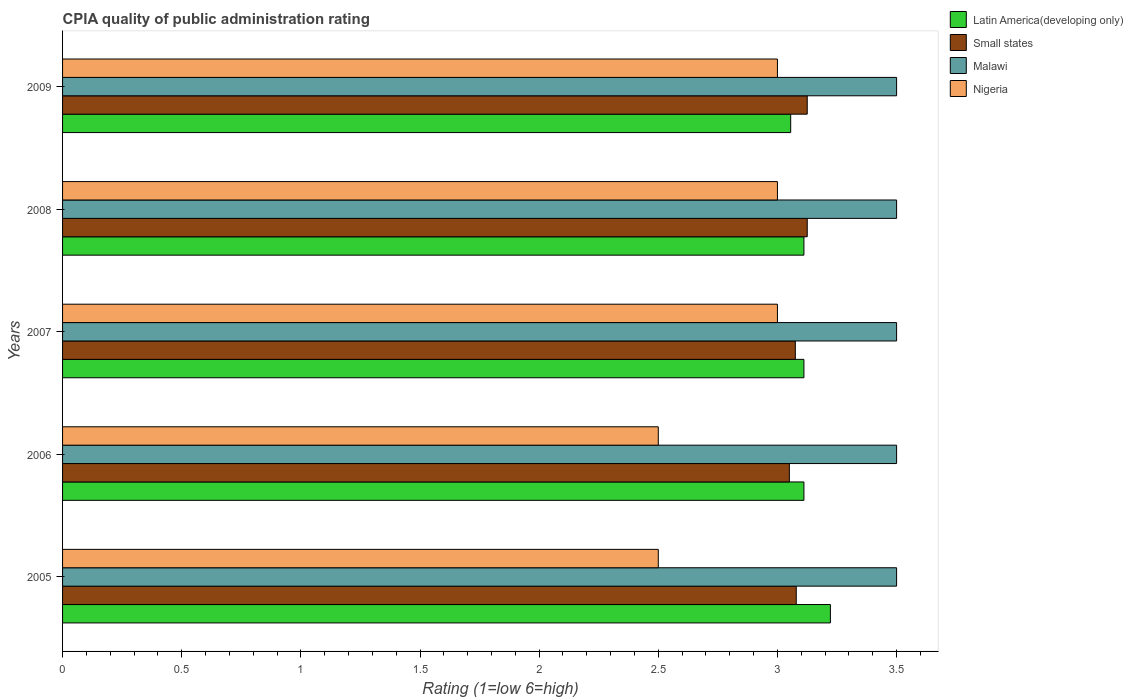How many groups of bars are there?
Keep it short and to the point. 5. Are the number of bars on each tick of the Y-axis equal?
Provide a succinct answer. Yes. What is the label of the 4th group of bars from the top?
Give a very brief answer. 2006. What is the CPIA rating in Small states in 2007?
Make the answer very short. 3.08. Across all years, what is the maximum CPIA rating in Small states?
Your answer should be compact. 3.12. Across all years, what is the minimum CPIA rating in Small states?
Your response must be concise. 3.05. In which year was the CPIA rating in Malawi maximum?
Your response must be concise. 2005. In which year was the CPIA rating in Malawi minimum?
Provide a short and direct response. 2005. What is the total CPIA rating in Nigeria in the graph?
Ensure brevity in your answer.  14. What is the difference between the CPIA rating in Latin America(developing only) in 2009 and the CPIA rating in Small states in 2007?
Keep it short and to the point. -0.02. In the year 2006, what is the difference between the CPIA rating in Malawi and CPIA rating in Latin America(developing only)?
Provide a short and direct response. 0.39. Is the difference between the CPIA rating in Malawi in 2006 and 2008 greater than the difference between the CPIA rating in Latin America(developing only) in 2006 and 2008?
Your answer should be compact. No. What is the difference between the highest and the second highest CPIA rating in Small states?
Keep it short and to the point. 0. What is the difference between the highest and the lowest CPIA rating in Latin America(developing only)?
Your answer should be compact. 0.17. What does the 3rd bar from the top in 2006 represents?
Ensure brevity in your answer.  Small states. What does the 2nd bar from the bottom in 2006 represents?
Your answer should be compact. Small states. Is it the case that in every year, the sum of the CPIA rating in Nigeria and CPIA rating in Small states is greater than the CPIA rating in Latin America(developing only)?
Keep it short and to the point. Yes. Are all the bars in the graph horizontal?
Your answer should be very brief. Yes. Does the graph contain any zero values?
Offer a terse response. No. What is the title of the graph?
Keep it short and to the point. CPIA quality of public administration rating. What is the label or title of the X-axis?
Ensure brevity in your answer.  Rating (1=low 6=high). What is the label or title of the Y-axis?
Your answer should be compact. Years. What is the Rating (1=low 6=high) in Latin America(developing only) in 2005?
Provide a succinct answer. 3.22. What is the Rating (1=low 6=high) in Small states in 2005?
Offer a terse response. 3.08. What is the Rating (1=low 6=high) of Nigeria in 2005?
Your answer should be very brief. 2.5. What is the Rating (1=low 6=high) in Latin America(developing only) in 2006?
Provide a succinct answer. 3.11. What is the Rating (1=low 6=high) of Small states in 2006?
Make the answer very short. 3.05. What is the Rating (1=low 6=high) in Nigeria in 2006?
Offer a terse response. 2.5. What is the Rating (1=low 6=high) of Latin America(developing only) in 2007?
Offer a very short reply. 3.11. What is the Rating (1=low 6=high) in Small states in 2007?
Keep it short and to the point. 3.08. What is the Rating (1=low 6=high) of Malawi in 2007?
Give a very brief answer. 3.5. What is the Rating (1=low 6=high) of Nigeria in 2007?
Give a very brief answer. 3. What is the Rating (1=low 6=high) of Latin America(developing only) in 2008?
Offer a very short reply. 3.11. What is the Rating (1=low 6=high) in Small states in 2008?
Offer a terse response. 3.12. What is the Rating (1=low 6=high) in Nigeria in 2008?
Your response must be concise. 3. What is the Rating (1=low 6=high) of Latin America(developing only) in 2009?
Give a very brief answer. 3.06. What is the Rating (1=low 6=high) in Small states in 2009?
Offer a terse response. 3.12. What is the Rating (1=low 6=high) of Malawi in 2009?
Make the answer very short. 3.5. Across all years, what is the maximum Rating (1=low 6=high) in Latin America(developing only)?
Your answer should be very brief. 3.22. Across all years, what is the maximum Rating (1=low 6=high) in Small states?
Your response must be concise. 3.12. Across all years, what is the maximum Rating (1=low 6=high) in Malawi?
Ensure brevity in your answer.  3.5. Across all years, what is the minimum Rating (1=low 6=high) of Latin America(developing only)?
Your answer should be very brief. 3.06. Across all years, what is the minimum Rating (1=low 6=high) in Small states?
Make the answer very short. 3.05. Across all years, what is the minimum Rating (1=low 6=high) in Malawi?
Offer a terse response. 3.5. What is the total Rating (1=low 6=high) in Latin America(developing only) in the graph?
Offer a very short reply. 15.61. What is the total Rating (1=low 6=high) in Small states in the graph?
Make the answer very short. 15.45. What is the total Rating (1=low 6=high) in Malawi in the graph?
Offer a very short reply. 17.5. What is the difference between the Rating (1=low 6=high) in Latin America(developing only) in 2005 and that in 2006?
Your answer should be very brief. 0.11. What is the difference between the Rating (1=low 6=high) in Small states in 2005 and that in 2006?
Give a very brief answer. 0.03. What is the difference between the Rating (1=low 6=high) of Malawi in 2005 and that in 2006?
Offer a very short reply. 0. What is the difference between the Rating (1=low 6=high) in Small states in 2005 and that in 2007?
Make the answer very short. 0. What is the difference between the Rating (1=low 6=high) in Nigeria in 2005 and that in 2007?
Make the answer very short. -0.5. What is the difference between the Rating (1=low 6=high) in Latin America(developing only) in 2005 and that in 2008?
Make the answer very short. 0.11. What is the difference between the Rating (1=low 6=high) of Small states in 2005 and that in 2008?
Provide a succinct answer. -0.05. What is the difference between the Rating (1=low 6=high) of Nigeria in 2005 and that in 2008?
Offer a very short reply. -0.5. What is the difference between the Rating (1=low 6=high) of Small states in 2005 and that in 2009?
Your response must be concise. -0.05. What is the difference between the Rating (1=low 6=high) in Small states in 2006 and that in 2007?
Provide a short and direct response. -0.03. What is the difference between the Rating (1=low 6=high) of Malawi in 2006 and that in 2007?
Keep it short and to the point. 0. What is the difference between the Rating (1=low 6=high) of Small states in 2006 and that in 2008?
Give a very brief answer. -0.07. What is the difference between the Rating (1=low 6=high) of Nigeria in 2006 and that in 2008?
Ensure brevity in your answer.  -0.5. What is the difference between the Rating (1=low 6=high) in Latin America(developing only) in 2006 and that in 2009?
Keep it short and to the point. 0.06. What is the difference between the Rating (1=low 6=high) of Small states in 2006 and that in 2009?
Ensure brevity in your answer.  -0.07. What is the difference between the Rating (1=low 6=high) of Malawi in 2006 and that in 2009?
Offer a very short reply. 0. What is the difference between the Rating (1=low 6=high) of Nigeria in 2006 and that in 2009?
Provide a short and direct response. -0.5. What is the difference between the Rating (1=low 6=high) of Small states in 2007 and that in 2008?
Your answer should be very brief. -0.05. What is the difference between the Rating (1=low 6=high) of Malawi in 2007 and that in 2008?
Ensure brevity in your answer.  0. What is the difference between the Rating (1=low 6=high) of Nigeria in 2007 and that in 2008?
Provide a short and direct response. 0. What is the difference between the Rating (1=low 6=high) in Latin America(developing only) in 2007 and that in 2009?
Offer a terse response. 0.06. What is the difference between the Rating (1=low 6=high) of Small states in 2007 and that in 2009?
Your answer should be compact. -0.05. What is the difference between the Rating (1=low 6=high) of Malawi in 2007 and that in 2009?
Offer a very short reply. 0. What is the difference between the Rating (1=low 6=high) of Nigeria in 2007 and that in 2009?
Offer a terse response. 0. What is the difference between the Rating (1=low 6=high) in Latin America(developing only) in 2008 and that in 2009?
Offer a very short reply. 0.06. What is the difference between the Rating (1=low 6=high) in Latin America(developing only) in 2005 and the Rating (1=low 6=high) in Small states in 2006?
Keep it short and to the point. 0.17. What is the difference between the Rating (1=low 6=high) in Latin America(developing only) in 2005 and the Rating (1=low 6=high) in Malawi in 2006?
Keep it short and to the point. -0.28. What is the difference between the Rating (1=low 6=high) of Latin America(developing only) in 2005 and the Rating (1=low 6=high) of Nigeria in 2006?
Provide a succinct answer. 0.72. What is the difference between the Rating (1=low 6=high) of Small states in 2005 and the Rating (1=low 6=high) of Malawi in 2006?
Offer a terse response. -0.42. What is the difference between the Rating (1=low 6=high) in Small states in 2005 and the Rating (1=low 6=high) in Nigeria in 2006?
Your response must be concise. 0.58. What is the difference between the Rating (1=low 6=high) of Latin America(developing only) in 2005 and the Rating (1=low 6=high) of Small states in 2007?
Offer a terse response. 0.15. What is the difference between the Rating (1=low 6=high) of Latin America(developing only) in 2005 and the Rating (1=low 6=high) of Malawi in 2007?
Your answer should be compact. -0.28. What is the difference between the Rating (1=low 6=high) of Latin America(developing only) in 2005 and the Rating (1=low 6=high) of Nigeria in 2007?
Your answer should be compact. 0.22. What is the difference between the Rating (1=low 6=high) in Small states in 2005 and the Rating (1=low 6=high) in Malawi in 2007?
Offer a very short reply. -0.42. What is the difference between the Rating (1=low 6=high) of Small states in 2005 and the Rating (1=low 6=high) of Nigeria in 2007?
Your answer should be very brief. 0.08. What is the difference between the Rating (1=low 6=high) of Latin America(developing only) in 2005 and the Rating (1=low 6=high) of Small states in 2008?
Your answer should be compact. 0.1. What is the difference between the Rating (1=low 6=high) in Latin America(developing only) in 2005 and the Rating (1=low 6=high) in Malawi in 2008?
Your answer should be very brief. -0.28. What is the difference between the Rating (1=low 6=high) of Latin America(developing only) in 2005 and the Rating (1=low 6=high) of Nigeria in 2008?
Provide a succinct answer. 0.22. What is the difference between the Rating (1=low 6=high) in Small states in 2005 and the Rating (1=low 6=high) in Malawi in 2008?
Offer a very short reply. -0.42. What is the difference between the Rating (1=low 6=high) of Small states in 2005 and the Rating (1=low 6=high) of Nigeria in 2008?
Your answer should be compact. 0.08. What is the difference between the Rating (1=low 6=high) in Malawi in 2005 and the Rating (1=low 6=high) in Nigeria in 2008?
Provide a succinct answer. 0.5. What is the difference between the Rating (1=low 6=high) in Latin America(developing only) in 2005 and the Rating (1=low 6=high) in Small states in 2009?
Offer a terse response. 0.1. What is the difference between the Rating (1=low 6=high) of Latin America(developing only) in 2005 and the Rating (1=low 6=high) of Malawi in 2009?
Offer a very short reply. -0.28. What is the difference between the Rating (1=low 6=high) of Latin America(developing only) in 2005 and the Rating (1=low 6=high) of Nigeria in 2009?
Keep it short and to the point. 0.22. What is the difference between the Rating (1=low 6=high) of Small states in 2005 and the Rating (1=low 6=high) of Malawi in 2009?
Keep it short and to the point. -0.42. What is the difference between the Rating (1=low 6=high) in Small states in 2005 and the Rating (1=low 6=high) in Nigeria in 2009?
Give a very brief answer. 0.08. What is the difference between the Rating (1=low 6=high) of Malawi in 2005 and the Rating (1=low 6=high) of Nigeria in 2009?
Provide a succinct answer. 0.5. What is the difference between the Rating (1=low 6=high) of Latin America(developing only) in 2006 and the Rating (1=low 6=high) of Small states in 2007?
Your response must be concise. 0.04. What is the difference between the Rating (1=low 6=high) in Latin America(developing only) in 2006 and the Rating (1=low 6=high) in Malawi in 2007?
Your response must be concise. -0.39. What is the difference between the Rating (1=low 6=high) in Small states in 2006 and the Rating (1=low 6=high) in Malawi in 2007?
Offer a terse response. -0.45. What is the difference between the Rating (1=low 6=high) of Small states in 2006 and the Rating (1=low 6=high) of Nigeria in 2007?
Keep it short and to the point. 0.05. What is the difference between the Rating (1=low 6=high) in Malawi in 2006 and the Rating (1=low 6=high) in Nigeria in 2007?
Provide a succinct answer. 0.5. What is the difference between the Rating (1=low 6=high) of Latin America(developing only) in 2006 and the Rating (1=low 6=high) of Small states in 2008?
Your response must be concise. -0.01. What is the difference between the Rating (1=low 6=high) of Latin America(developing only) in 2006 and the Rating (1=low 6=high) of Malawi in 2008?
Make the answer very short. -0.39. What is the difference between the Rating (1=low 6=high) in Small states in 2006 and the Rating (1=low 6=high) in Malawi in 2008?
Make the answer very short. -0.45. What is the difference between the Rating (1=low 6=high) of Latin America(developing only) in 2006 and the Rating (1=low 6=high) of Small states in 2009?
Make the answer very short. -0.01. What is the difference between the Rating (1=low 6=high) of Latin America(developing only) in 2006 and the Rating (1=low 6=high) of Malawi in 2009?
Your response must be concise. -0.39. What is the difference between the Rating (1=low 6=high) of Small states in 2006 and the Rating (1=low 6=high) of Malawi in 2009?
Your answer should be very brief. -0.45. What is the difference between the Rating (1=low 6=high) in Small states in 2006 and the Rating (1=low 6=high) in Nigeria in 2009?
Give a very brief answer. 0.05. What is the difference between the Rating (1=low 6=high) in Malawi in 2006 and the Rating (1=low 6=high) in Nigeria in 2009?
Give a very brief answer. 0.5. What is the difference between the Rating (1=low 6=high) in Latin America(developing only) in 2007 and the Rating (1=low 6=high) in Small states in 2008?
Provide a short and direct response. -0.01. What is the difference between the Rating (1=low 6=high) of Latin America(developing only) in 2007 and the Rating (1=low 6=high) of Malawi in 2008?
Keep it short and to the point. -0.39. What is the difference between the Rating (1=low 6=high) of Latin America(developing only) in 2007 and the Rating (1=low 6=high) of Nigeria in 2008?
Offer a terse response. 0.11. What is the difference between the Rating (1=low 6=high) of Small states in 2007 and the Rating (1=low 6=high) of Malawi in 2008?
Ensure brevity in your answer.  -0.42. What is the difference between the Rating (1=low 6=high) in Small states in 2007 and the Rating (1=low 6=high) in Nigeria in 2008?
Your answer should be very brief. 0.07. What is the difference between the Rating (1=low 6=high) of Latin America(developing only) in 2007 and the Rating (1=low 6=high) of Small states in 2009?
Offer a very short reply. -0.01. What is the difference between the Rating (1=low 6=high) in Latin America(developing only) in 2007 and the Rating (1=low 6=high) in Malawi in 2009?
Offer a very short reply. -0.39. What is the difference between the Rating (1=low 6=high) in Small states in 2007 and the Rating (1=low 6=high) in Malawi in 2009?
Offer a very short reply. -0.42. What is the difference between the Rating (1=low 6=high) in Small states in 2007 and the Rating (1=low 6=high) in Nigeria in 2009?
Ensure brevity in your answer.  0.07. What is the difference between the Rating (1=low 6=high) in Latin America(developing only) in 2008 and the Rating (1=low 6=high) in Small states in 2009?
Provide a succinct answer. -0.01. What is the difference between the Rating (1=low 6=high) in Latin America(developing only) in 2008 and the Rating (1=low 6=high) in Malawi in 2009?
Your answer should be very brief. -0.39. What is the difference between the Rating (1=low 6=high) of Latin America(developing only) in 2008 and the Rating (1=low 6=high) of Nigeria in 2009?
Provide a succinct answer. 0.11. What is the difference between the Rating (1=low 6=high) in Small states in 2008 and the Rating (1=low 6=high) in Malawi in 2009?
Your answer should be very brief. -0.38. What is the difference between the Rating (1=low 6=high) in Small states in 2008 and the Rating (1=low 6=high) in Nigeria in 2009?
Ensure brevity in your answer.  0.12. What is the average Rating (1=low 6=high) of Latin America(developing only) per year?
Provide a succinct answer. 3.12. What is the average Rating (1=low 6=high) in Small states per year?
Ensure brevity in your answer.  3.09. What is the average Rating (1=low 6=high) of Nigeria per year?
Keep it short and to the point. 2.8. In the year 2005, what is the difference between the Rating (1=low 6=high) of Latin America(developing only) and Rating (1=low 6=high) of Small states?
Your answer should be very brief. 0.14. In the year 2005, what is the difference between the Rating (1=low 6=high) of Latin America(developing only) and Rating (1=low 6=high) of Malawi?
Provide a short and direct response. -0.28. In the year 2005, what is the difference between the Rating (1=low 6=high) of Latin America(developing only) and Rating (1=low 6=high) of Nigeria?
Your answer should be compact. 0.72. In the year 2005, what is the difference between the Rating (1=low 6=high) in Small states and Rating (1=low 6=high) in Malawi?
Make the answer very short. -0.42. In the year 2005, what is the difference between the Rating (1=low 6=high) in Small states and Rating (1=low 6=high) in Nigeria?
Your response must be concise. 0.58. In the year 2006, what is the difference between the Rating (1=low 6=high) in Latin America(developing only) and Rating (1=low 6=high) in Small states?
Offer a terse response. 0.06. In the year 2006, what is the difference between the Rating (1=low 6=high) of Latin America(developing only) and Rating (1=low 6=high) of Malawi?
Provide a short and direct response. -0.39. In the year 2006, what is the difference between the Rating (1=low 6=high) in Latin America(developing only) and Rating (1=low 6=high) in Nigeria?
Your answer should be compact. 0.61. In the year 2006, what is the difference between the Rating (1=low 6=high) in Small states and Rating (1=low 6=high) in Malawi?
Your answer should be compact. -0.45. In the year 2006, what is the difference between the Rating (1=low 6=high) in Small states and Rating (1=low 6=high) in Nigeria?
Your response must be concise. 0.55. In the year 2006, what is the difference between the Rating (1=low 6=high) in Malawi and Rating (1=low 6=high) in Nigeria?
Offer a terse response. 1. In the year 2007, what is the difference between the Rating (1=low 6=high) of Latin America(developing only) and Rating (1=low 6=high) of Small states?
Make the answer very short. 0.04. In the year 2007, what is the difference between the Rating (1=low 6=high) in Latin America(developing only) and Rating (1=low 6=high) in Malawi?
Keep it short and to the point. -0.39. In the year 2007, what is the difference between the Rating (1=low 6=high) in Latin America(developing only) and Rating (1=low 6=high) in Nigeria?
Keep it short and to the point. 0.11. In the year 2007, what is the difference between the Rating (1=low 6=high) of Small states and Rating (1=low 6=high) of Malawi?
Make the answer very short. -0.42. In the year 2007, what is the difference between the Rating (1=low 6=high) in Small states and Rating (1=low 6=high) in Nigeria?
Your response must be concise. 0.07. In the year 2007, what is the difference between the Rating (1=low 6=high) in Malawi and Rating (1=low 6=high) in Nigeria?
Your answer should be very brief. 0.5. In the year 2008, what is the difference between the Rating (1=low 6=high) of Latin America(developing only) and Rating (1=low 6=high) of Small states?
Your answer should be compact. -0.01. In the year 2008, what is the difference between the Rating (1=low 6=high) of Latin America(developing only) and Rating (1=low 6=high) of Malawi?
Your answer should be compact. -0.39. In the year 2008, what is the difference between the Rating (1=low 6=high) in Latin America(developing only) and Rating (1=low 6=high) in Nigeria?
Ensure brevity in your answer.  0.11. In the year 2008, what is the difference between the Rating (1=low 6=high) of Small states and Rating (1=low 6=high) of Malawi?
Offer a terse response. -0.38. In the year 2008, what is the difference between the Rating (1=low 6=high) in Small states and Rating (1=low 6=high) in Nigeria?
Offer a very short reply. 0.12. In the year 2009, what is the difference between the Rating (1=low 6=high) in Latin America(developing only) and Rating (1=low 6=high) in Small states?
Offer a terse response. -0.07. In the year 2009, what is the difference between the Rating (1=low 6=high) in Latin America(developing only) and Rating (1=low 6=high) in Malawi?
Your answer should be very brief. -0.44. In the year 2009, what is the difference between the Rating (1=low 6=high) in Latin America(developing only) and Rating (1=low 6=high) in Nigeria?
Provide a succinct answer. 0.06. In the year 2009, what is the difference between the Rating (1=low 6=high) of Small states and Rating (1=low 6=high) of Malawi?
Offer a very short reply. -0.38. In the year 2009, what is the difference between the Rating (1=low 6=high) of Small states and Rating (1=low 6=high) of Nigeria?
Your answer should be very brief. 0.12. What is the ratio of the Rating (1=low 6=high) of Latin America(developing only) in 2005 to that in 2006?
Your answer should be compact. 1.04. What is the ratio of the Rating (1=low 6=high) of Small states in 2005 to that in 2006?
Provide a succinct answer. 1.01. What is the ratio of the Rating (1=low 6=high) of Malawi in 2005 to that in 2006?
Ensure brevity in your answer.  1. What is the ratio of the Rating (1=low 6=high) of Latin America(developing only) in 2005 to that in 2007?
Make the answer very short. 1.04. What is the ratio of the Rating (1=low 6=high) of Small states in 2005 to that in 2007?
Make the answer very short. 1. What is the ratio of the Rating (1=low 6=high) in Latin America(developing only) in 2005 to that in 2008?
Your response must be concise. 1.04. What is the ratio of the Rating (1=low 6=high) of Malawi in 2005 to that in 2008?
Ensure brevity in your answer.  1. What is the ratio of the Rating (1=low 6=high) in Latin America(developing only) in 2005 to that in 2009?
Provide a short and direct response. 1.05. What is the ratio of the Rating (1=low 6=high) in Malawi in 2005 to that in 2009?
Your response must be concise. 1. What is the ratio of the Rating (1=low 6=high) of Small states in 2006 to that in 2007?
Give a very brief answer. 0.99. What is the ratio of the Rating (1=low 6=high) of Malawi in 2006 to that in 2007?
Ensure brevity in your answer.  1. What is the ratio of the Rating (1=low 6=high) in Latin America(developing only) in 2006 to that in 2008?
Your response must be concise. 1. What is the ratio of the Rating (1=low 6=high) of Malawi in 2006 to that in 2008?
Your answer should be very brief. 1. What is the ratio of the Rating (1=low 6=high) in Nigeria in 2006 to that in 2008?
Ensure brevity in your answer.  0.83. What is the ratio of the Rating (1=low 6=high) in Latin America(developing only) in 2006 to that in 2009?
Your answer should be compact. 1.02. What is the ratio of the Rating (1=low 6=high) in Malawi in 2006 to that in 2009?
Ensure brevity in your answer.  1. What is the ratio of the Rating (1=low 6=high) in Small states in 2007 to that in 2008?
Provide a succinct answer. 0.98. What is the ratio of the Rating (1=low 6=high) in Malawi in 2007 to that in 2008?
Ensure brevity in your answer.  1. What is the ratio of the Rating (1=low 6=high) in Nigeria in 2007 to that in 2008?
Ensure brevity in your answer.  1. What is the ratio of the Rating (1=low 6=high) of Latin America(developing only) in 2007 to that in 2009?
Offer a terse response. 1.02. What is the ratio of the Rating (1=low 6=high) of Small states in 2007 to that in 2009?
Provide a short and direct response. 0.98. What is the ratio of the Rating (1=low 6=high) of Nigeria in 2007 to that in 2009?
Offer a terse response. 1. What is the ratio of the Rating (1=low 6=high) of Latin America(developing only) in 2008 to that in 2009?
Your answer should be very brief. 1.02. What is the ratio of the Rating (1=low 6=high) of Small states in 2008 to that in 2009?
Your response must be concise. 1. What is the ratio of the Rating (1=low 6=high) of Malawi in 2008 to that in 2009?
Make the answer very short. 1. What is the difference between the highest and the second highest Rating (1=low 6=high) of Small states?
Provide a succinct answer. 0. What is the difference between the highest and the second highest Rating (1=low 6=high) in Malawi?
Your answer should be compact. 0. What is the difference between the highest and the second highest Rating (1=low 6=high) of Nigeria?
Give a very brief answer. 0. What is the difference between the highest and the lowest Rating (1=low 6=high) in Small states?
Offer a very short reply. 0.07. What is the difference between the highest and the lowest Rating (1=low 6=high) in Malawi?
Make the answer very short. 0. What is the difference between the highest and the lowest Rating (1=low 6=high) of Nigeria?
Provide a short and direct response. 0.5. 